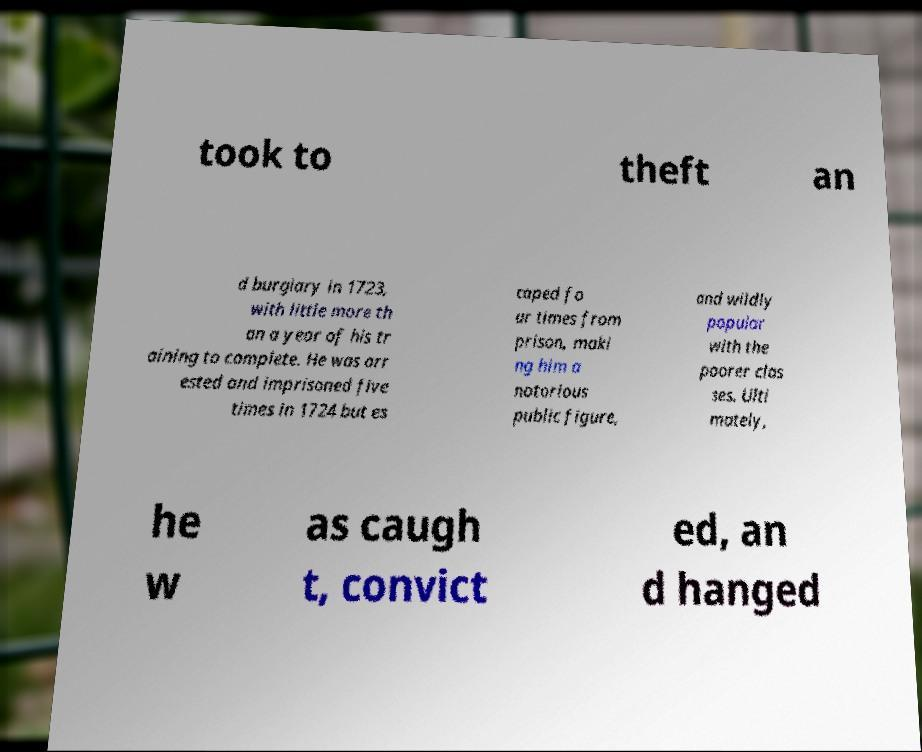Can you read and provide the text displayed in the image?This photo seems to have some interesting text. Can you extract and type it out for me? took to theft an d burglary in 1723, with little more th an a year of his tr aining to complete. He was arr ested and imprisoned five times in 1724 but es caped fo ur times from prison, maki ng him a notorious public figure, and wildly popular with the poorer clas ses. Ulti mately, he w as caugh t, convict ed, an d hanged 